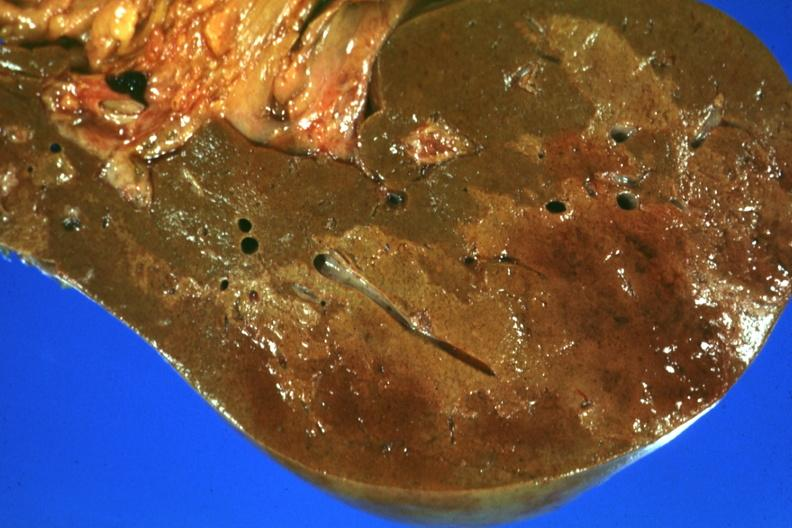s hepatobiliary present?
Answer the question using a single word or phrase. Yes 